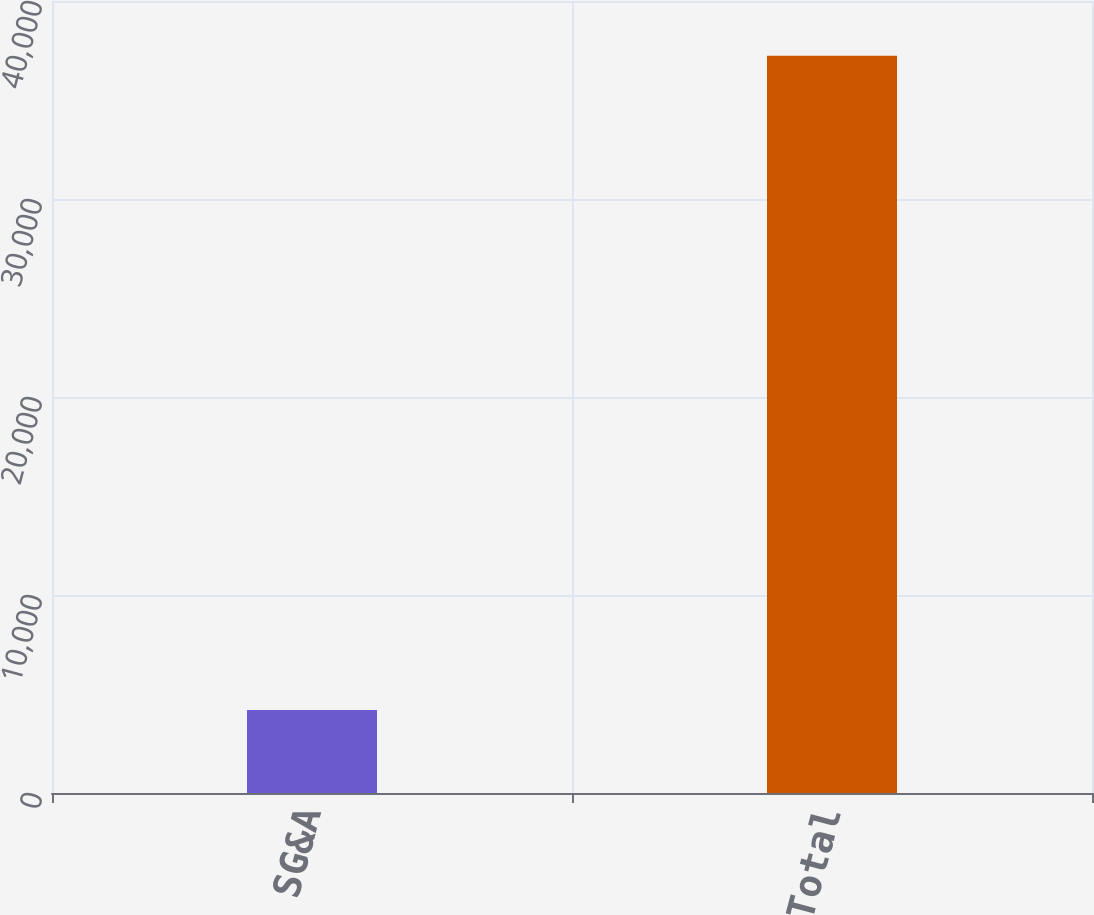Convert chart to OTSL. <chart><loc_0><loc_0><loc_500><loc_500><bar_chart><fcel>SG&A<fcel>Total<nl><fcel>4189<fcel>37239<nl></chart> 